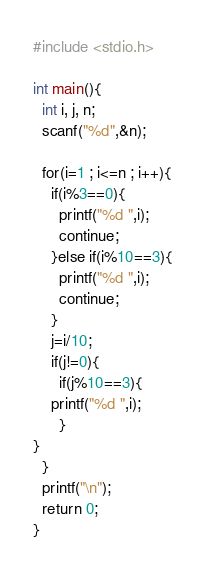Convert code to text. <code><loc_0><loc_0><loc_500><loc_500><_C_>#include <stdio.h>

int main(){
  int i, j, n;
  scanf("%d",&n);

  for(i=1 ; i<=n ; i++){
    if(i%3==0){
      printf("%d ",i);
      continue;
    }else if(i%10==3){
      printf("%d ",i);
      continue;
    }
    j=i/10;
    if(j!=0){
      if(j%10==3){
	printf("%d ",i);
      }
}
  }
  printf("\n");
  return 0;
}</code> 